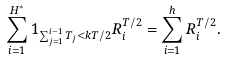Convert formula to latex. <formula><loc_0><loc_0><loc_500><loc_500>\sum _ { i = 1 } ^ { H ^ { * } } 1 _ { \sum _ { j = 1 } ^ { i - 1 } T _ { j } < k T / 2 } R _ { i } ^ { T / 2 } = \sum _ { i = 1 } ^ { h } R _ { i } ^ { T / 2 } .</formula> 